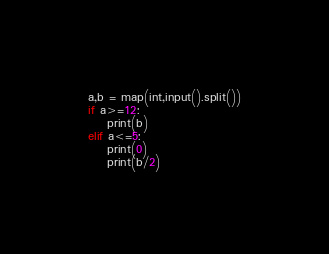Convert code to text. <code><loc_0><loc_0><loc_500><loc_500><_Python_>a,b = map(int,input().split())
if a>=12:
	print(b)
elif a<=5:
	print(0)
	print(b/2)</code> 